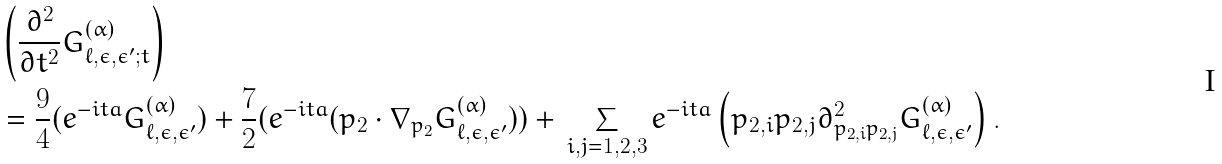<formula> <loc_0><loc_0><loc_500><loc_500>& \left ( \frac { \partial ^ { 2 } } { \partial t ^ { 2 } } G ^ { ( \alpha ) } _ { \ell , \epsilon , \epsilon ^ { \prime } ; t } \right ) \\ & = \frac { 9 } { 4 } ( e ^ { - i t a } G ^ { ( \alpha ) } _ { \ell , \epsilon , \epsilon ^ { \prime } } ) + \frac { 7 } { 2 } ( e ^ { - i t a } ( p _ { 2 } \cdot \nabla _ { p _ { 2 } } G ^ { ( \alpha ) } _ { \ell , \epsilon , \epsilon ^ { \prime } } ) ) + \, \sum _ { i , j = 1 , 2 , 3 } e ^ { - i t a } \left ( p _ { 2 , i } p _ { 2 , j } \partial ^ { 2 } _ { p _ { 2 , i } p _ { 2 , j } } G ^ { ( \alpha ) } _ { \ell , \epsilon , \epsilon ^ { \prime } } \right ) .</formula> 